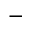Convert formula to latex. <formula><loc_0><loc_0><loc_500><loc_500>-</formula> 